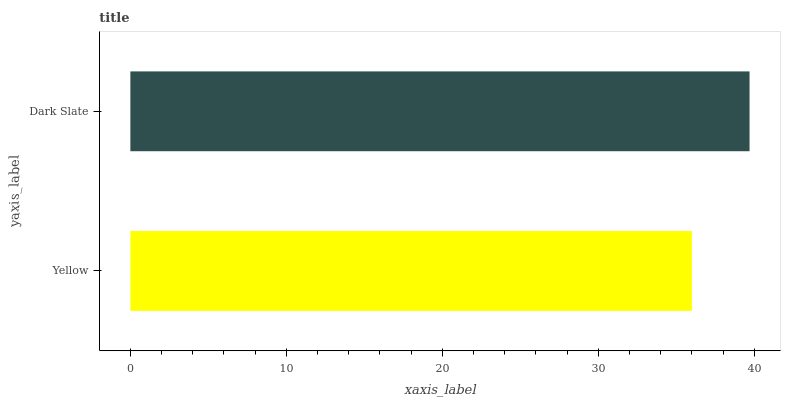Is Yellow the minimum?
Answer yes or no. Yes. Is Dark Slate the maximum?
Answer yes or no. Yes. Is Dark Slate the minimum?
Answer yes or no. No. Is Dark Slate greater than Yellow?
Answer yes or no. Yes. Is Yellow less than Dark Slate?
Answer yes or no. Yes. Is Yellow greater than Dark Slate?
Answer yes or no. No. Is Dark Slate less than Yellow?
Answer yes or no. No. Is Dark Slate the high median?
Answer yes or no. Yes. Is Yellow the low median?
Answer yes or no. Yes. Is Yellow the high median?
Answer yes or no. No. Is Dark Slate the low median?
Answer yes or no. No. 